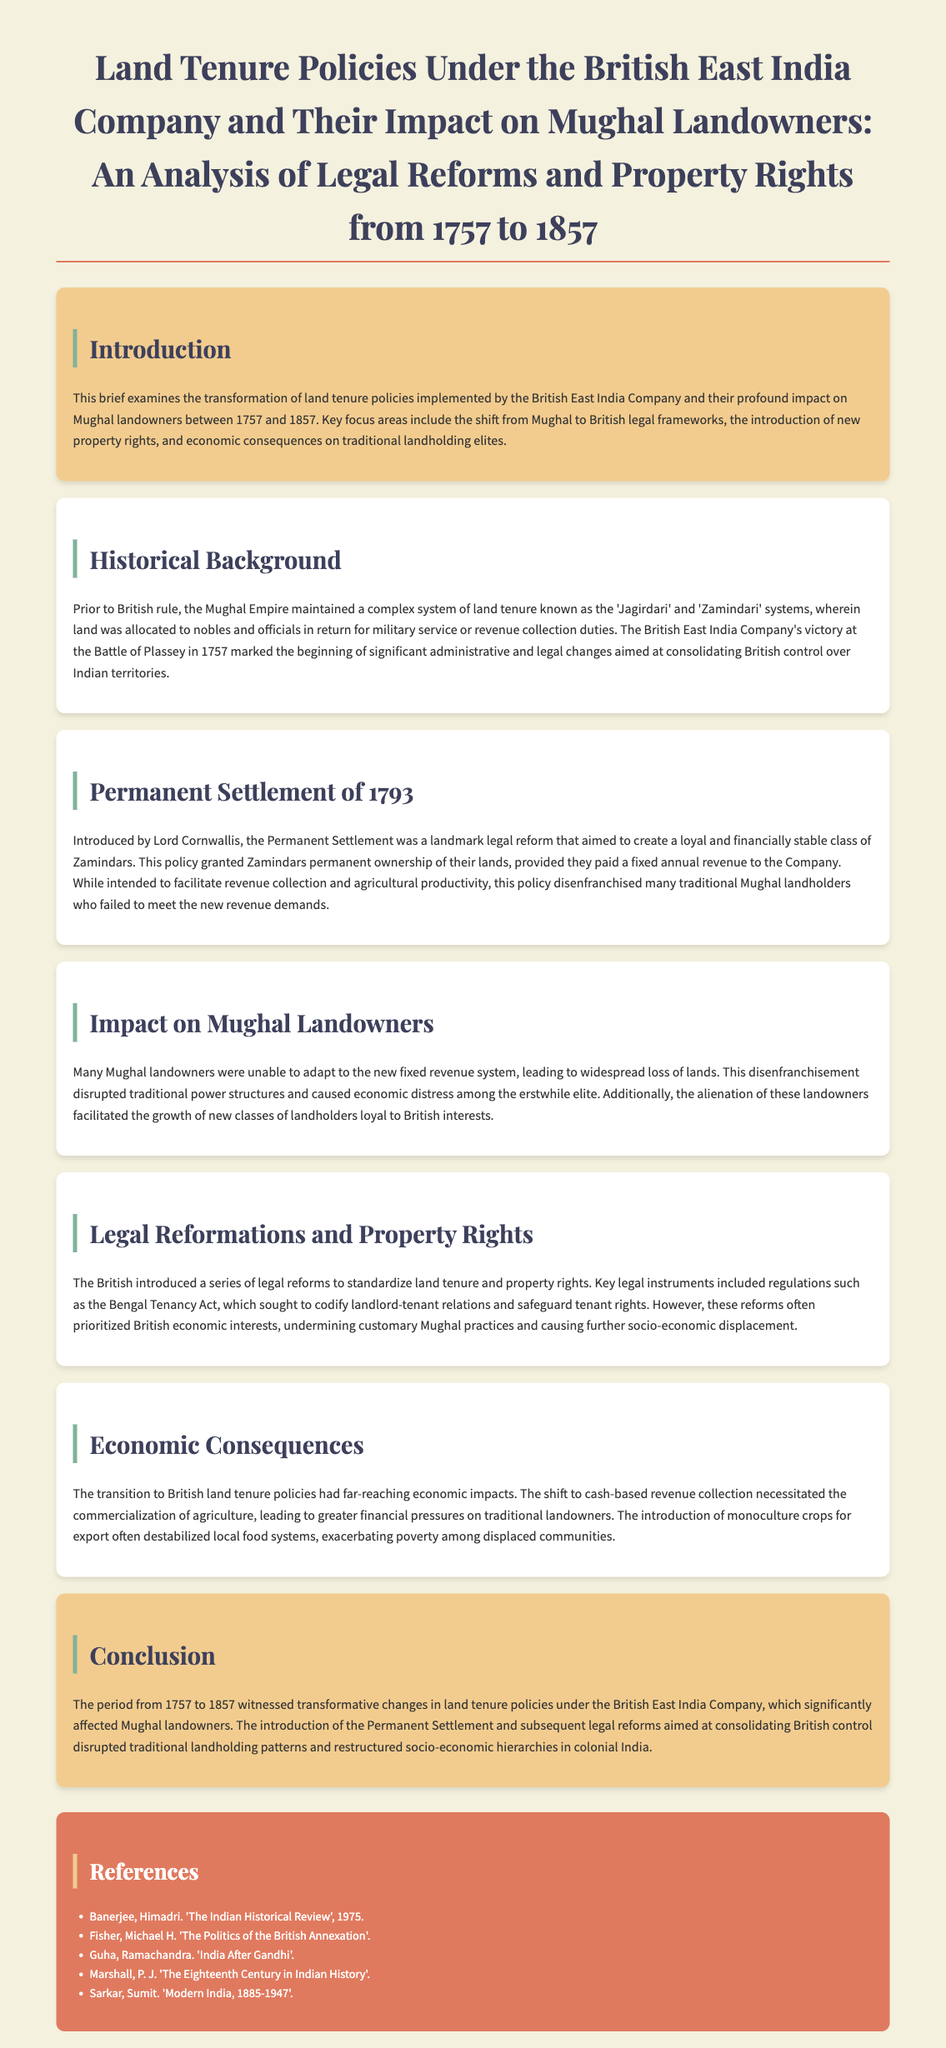What marked the beginning of significant changes in India? The British East India Company's victory at the Battle of Plassey in 1757 marked the beginning of significant administrative and legal changes.
Answer: Battle of Plassey Who introduced the Permanent Settlement? Lord Cornwallis introduced the Permanent Settlement in 1793.
Answer: Lord Cornwallis What was the focus of the Bengal Tenancy Act? The Bengal Tenancy Act sought to codify landlord-tenant relations and safeguard tenant rights.
Answer: Safeguard tenant rights What was one major economic consequence of the transition to British land tenure policies? The shift necessitated the commercialization of agriculture, leading to greater financial pressures on traditional landowners.
Answer: Commercialization of agriculture What did the transformation of land tenure policies disrupt? The transformation of land tenure policies disrupted traditional landholding patterns and restructured socio-economic hierarchies in colonial India.
Answer: Traditional landholding patterns What were Mughal landowners unable to adapt to? Many Mughal landowners were unable to adapt to the new fixed revenue system of the Permanent Settlement.
Answer: New fixed revenue system 